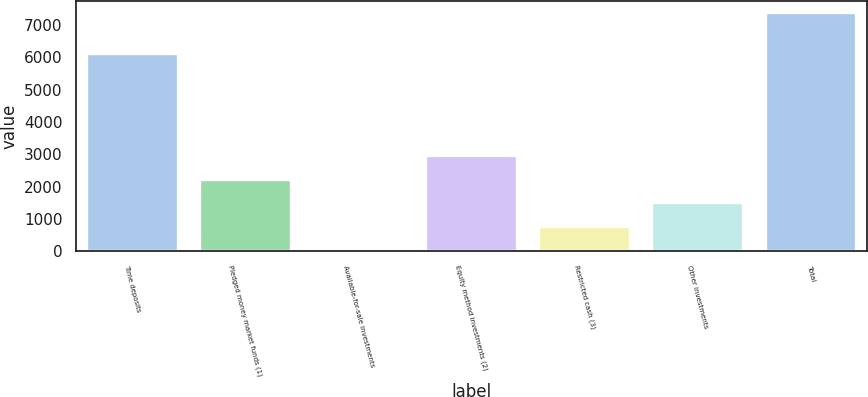<chart> <loc_0><loc_0><loc_500><loc_500><bar_chart><fcel>Time deposits<fcel>Pledged money market funds (1)<fcel>Available-for-sale investments<fcel>Equity method investments (2)<fcel>Restricted cash (3)<fcel>Other investments<fcel>Total<nl><fcel>6090<fcel>2217.8<fcel>8<fcel>2954.4<fcel>744.6<fcel>1481.2<fcel>7374<nl></chart> 